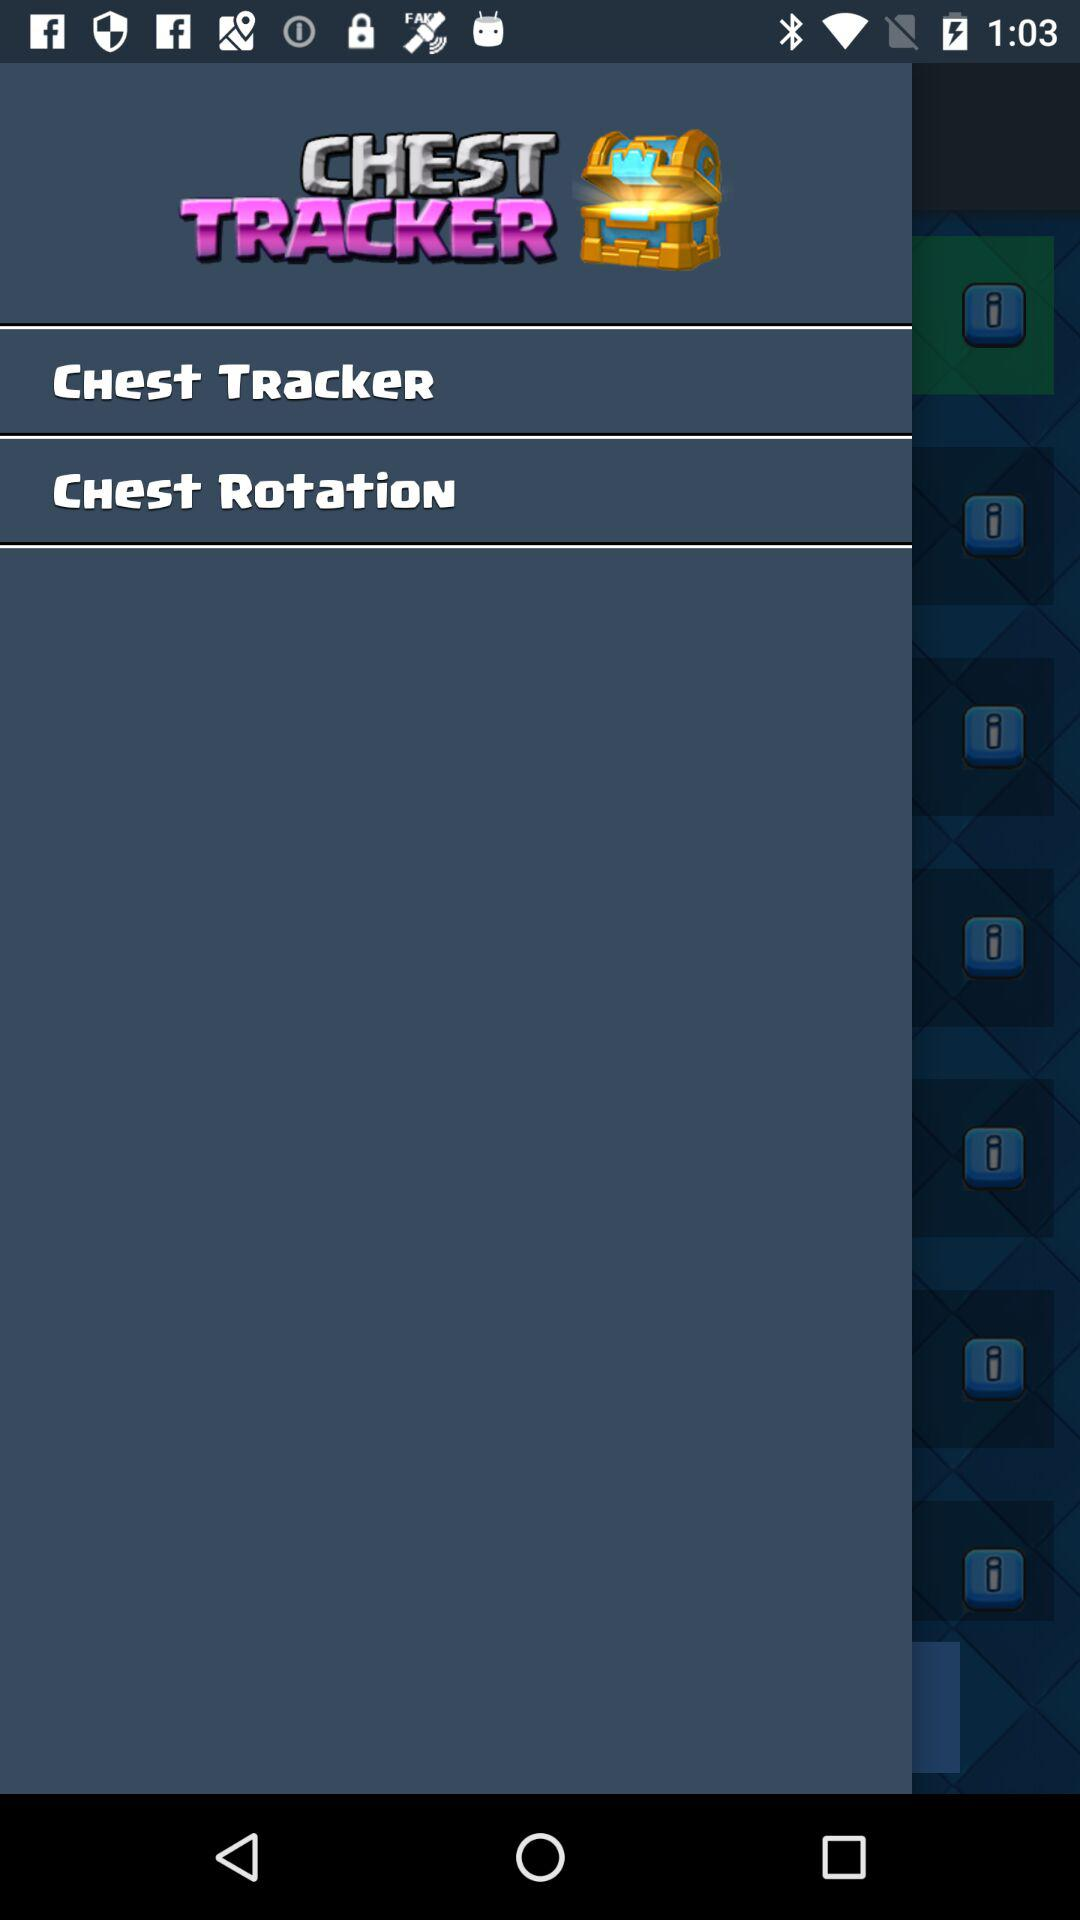What is the name of the application? The name of the application is "CHEST TRACKER". 